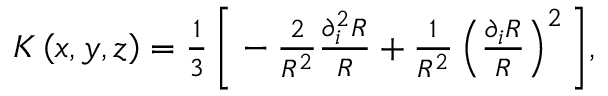<formula> <loc_0><loc_0><loc_500><loc_500>\begin{array} { r } { K \left ( x , y , z \right ) = \frac { 1 } { 3 } \, \left [ - \frac { 2 } { R ^ { 2 } } \frac { \partial _ { i } ^ { 2 } R } { R } + \frac { 1 } { R ^ { 2 } } \left ( \frac { \partial _ { i } R } { R } \right ) ^ { 2 } \right ] , } \end{array}</formula> 